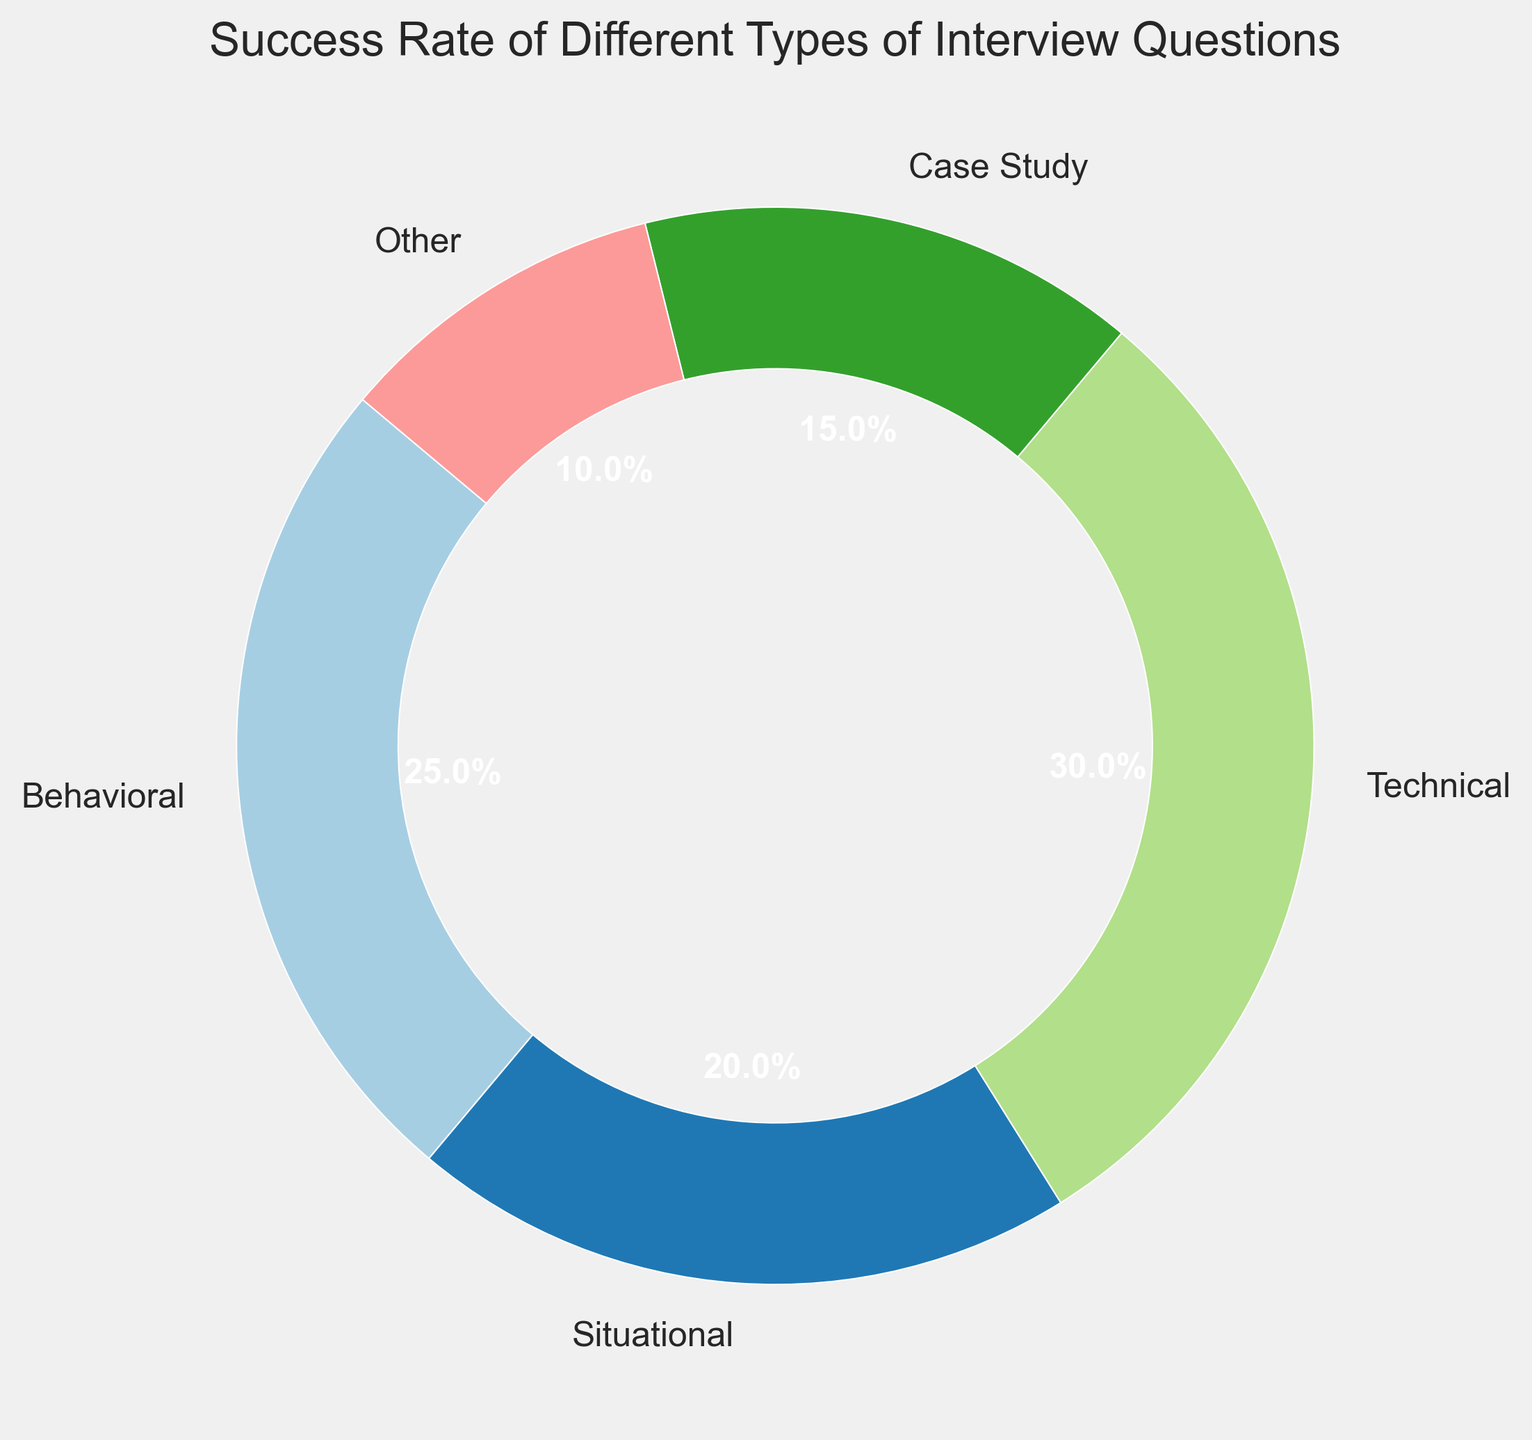How many types of interview questions are shown in the pie chart? By counting the number of distinct segments (or labels) in the pie chart, we see 5 types labeled as Behavioral, Situational, Technical, Case Study, and Other.
Answer: 5 Which type of interview question has the highest success rate? By examining the labels and their corresponding percentages, the Technical type has the highest success rate at 30%.
Answer: Technical What is the combined success rate of Behavioral and Situational questions? Add the success rates of Behavioral (25%) and Situational (20%), which gives 25% + 20% = 45%.
Answer: 45% Are there any types of interview questions with a success rate of 10% or less? By reviewing the success rates, we see that the 'Other' category has a success rate of 10%, which matches the condition.
Answer: Yes How much greater is the success rate of Technical questions compared to Case Study questions? Subtract the success rate of Case Study (15%) from Technical (30%), giving 30% - 15% = 15%.
Answer: 15% What percentage of the total success rate do "Technical" and "Case Study" questions together represent? Add the success rates of Technical (30%) and Case Study (15%), which gives 30% + 15% = 45%.
Answer: 45% Which interview question type has a success rate closest to 20% and is greater or equal to it? The Situational interview question type has a success rate exactly at 20%.
Answer: Situational Is the success rate of Behavioral questions more than double that of the "Other" category? Calculate double the success rate of 'Other' (10% * 2 = 20%) and compare it to Behavioral (25%). Since 25% > 20%, Behavioral is indeed more than double.
Answer: Yes If the success rate of Technical questions is considered a benchmark, which types have a lower success rate? Compare each type to Technical's 30% success rate. Behavioral (25%), Situational (20%), Case Study (15%), and Other (10%) all have lower success rates.
Answer: Behavioral, Situational, Case Study, Other What is the average success rate of all the interview question types shown? Add all the success rates: 25% (Behavioral) + 20% (Situational) + 30% (Technical) + 15% (Case Study) + 10% (Other) = 100%. Divide by the number of types (5), so 100% / 5 = 20%.
Answer: 20% 